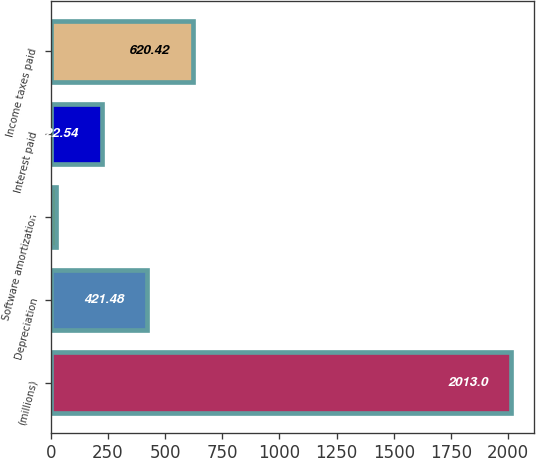Convert chart to OTSL. <chart><loc_0><loc_0><loc_500><loc_500><bar_chart><fcel>(millions)<fcel>Depreciation<fcel>Software amortization<fcel>Interest paid<fcel>Income taxes paid<nl><fcel>2013<fcel>421.48<fcel>23.6<fcel>222.54<fcel>620.42<nl></chart> 